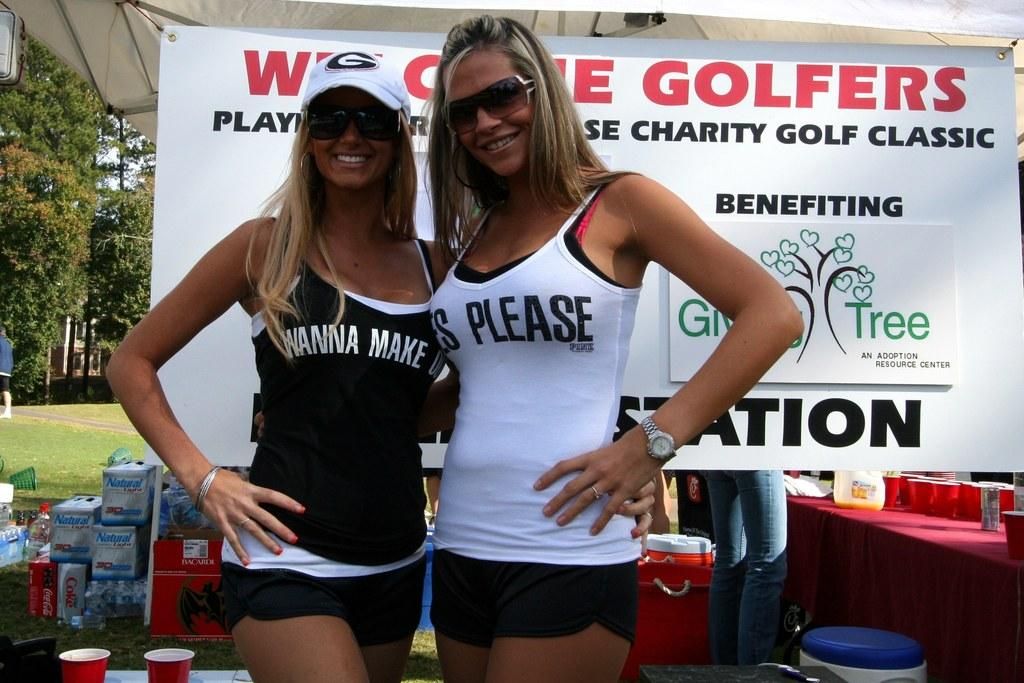What is happening in the center of the image? There are women standing in the center of the image. What can be seen in the background of the image? There is a poster, trees, glasses, a person, and containers in the background of the image. How many snails are crawling on the poster in the background? There are no snails present in the image, so it is not possible to determine how many might be on the poster. 